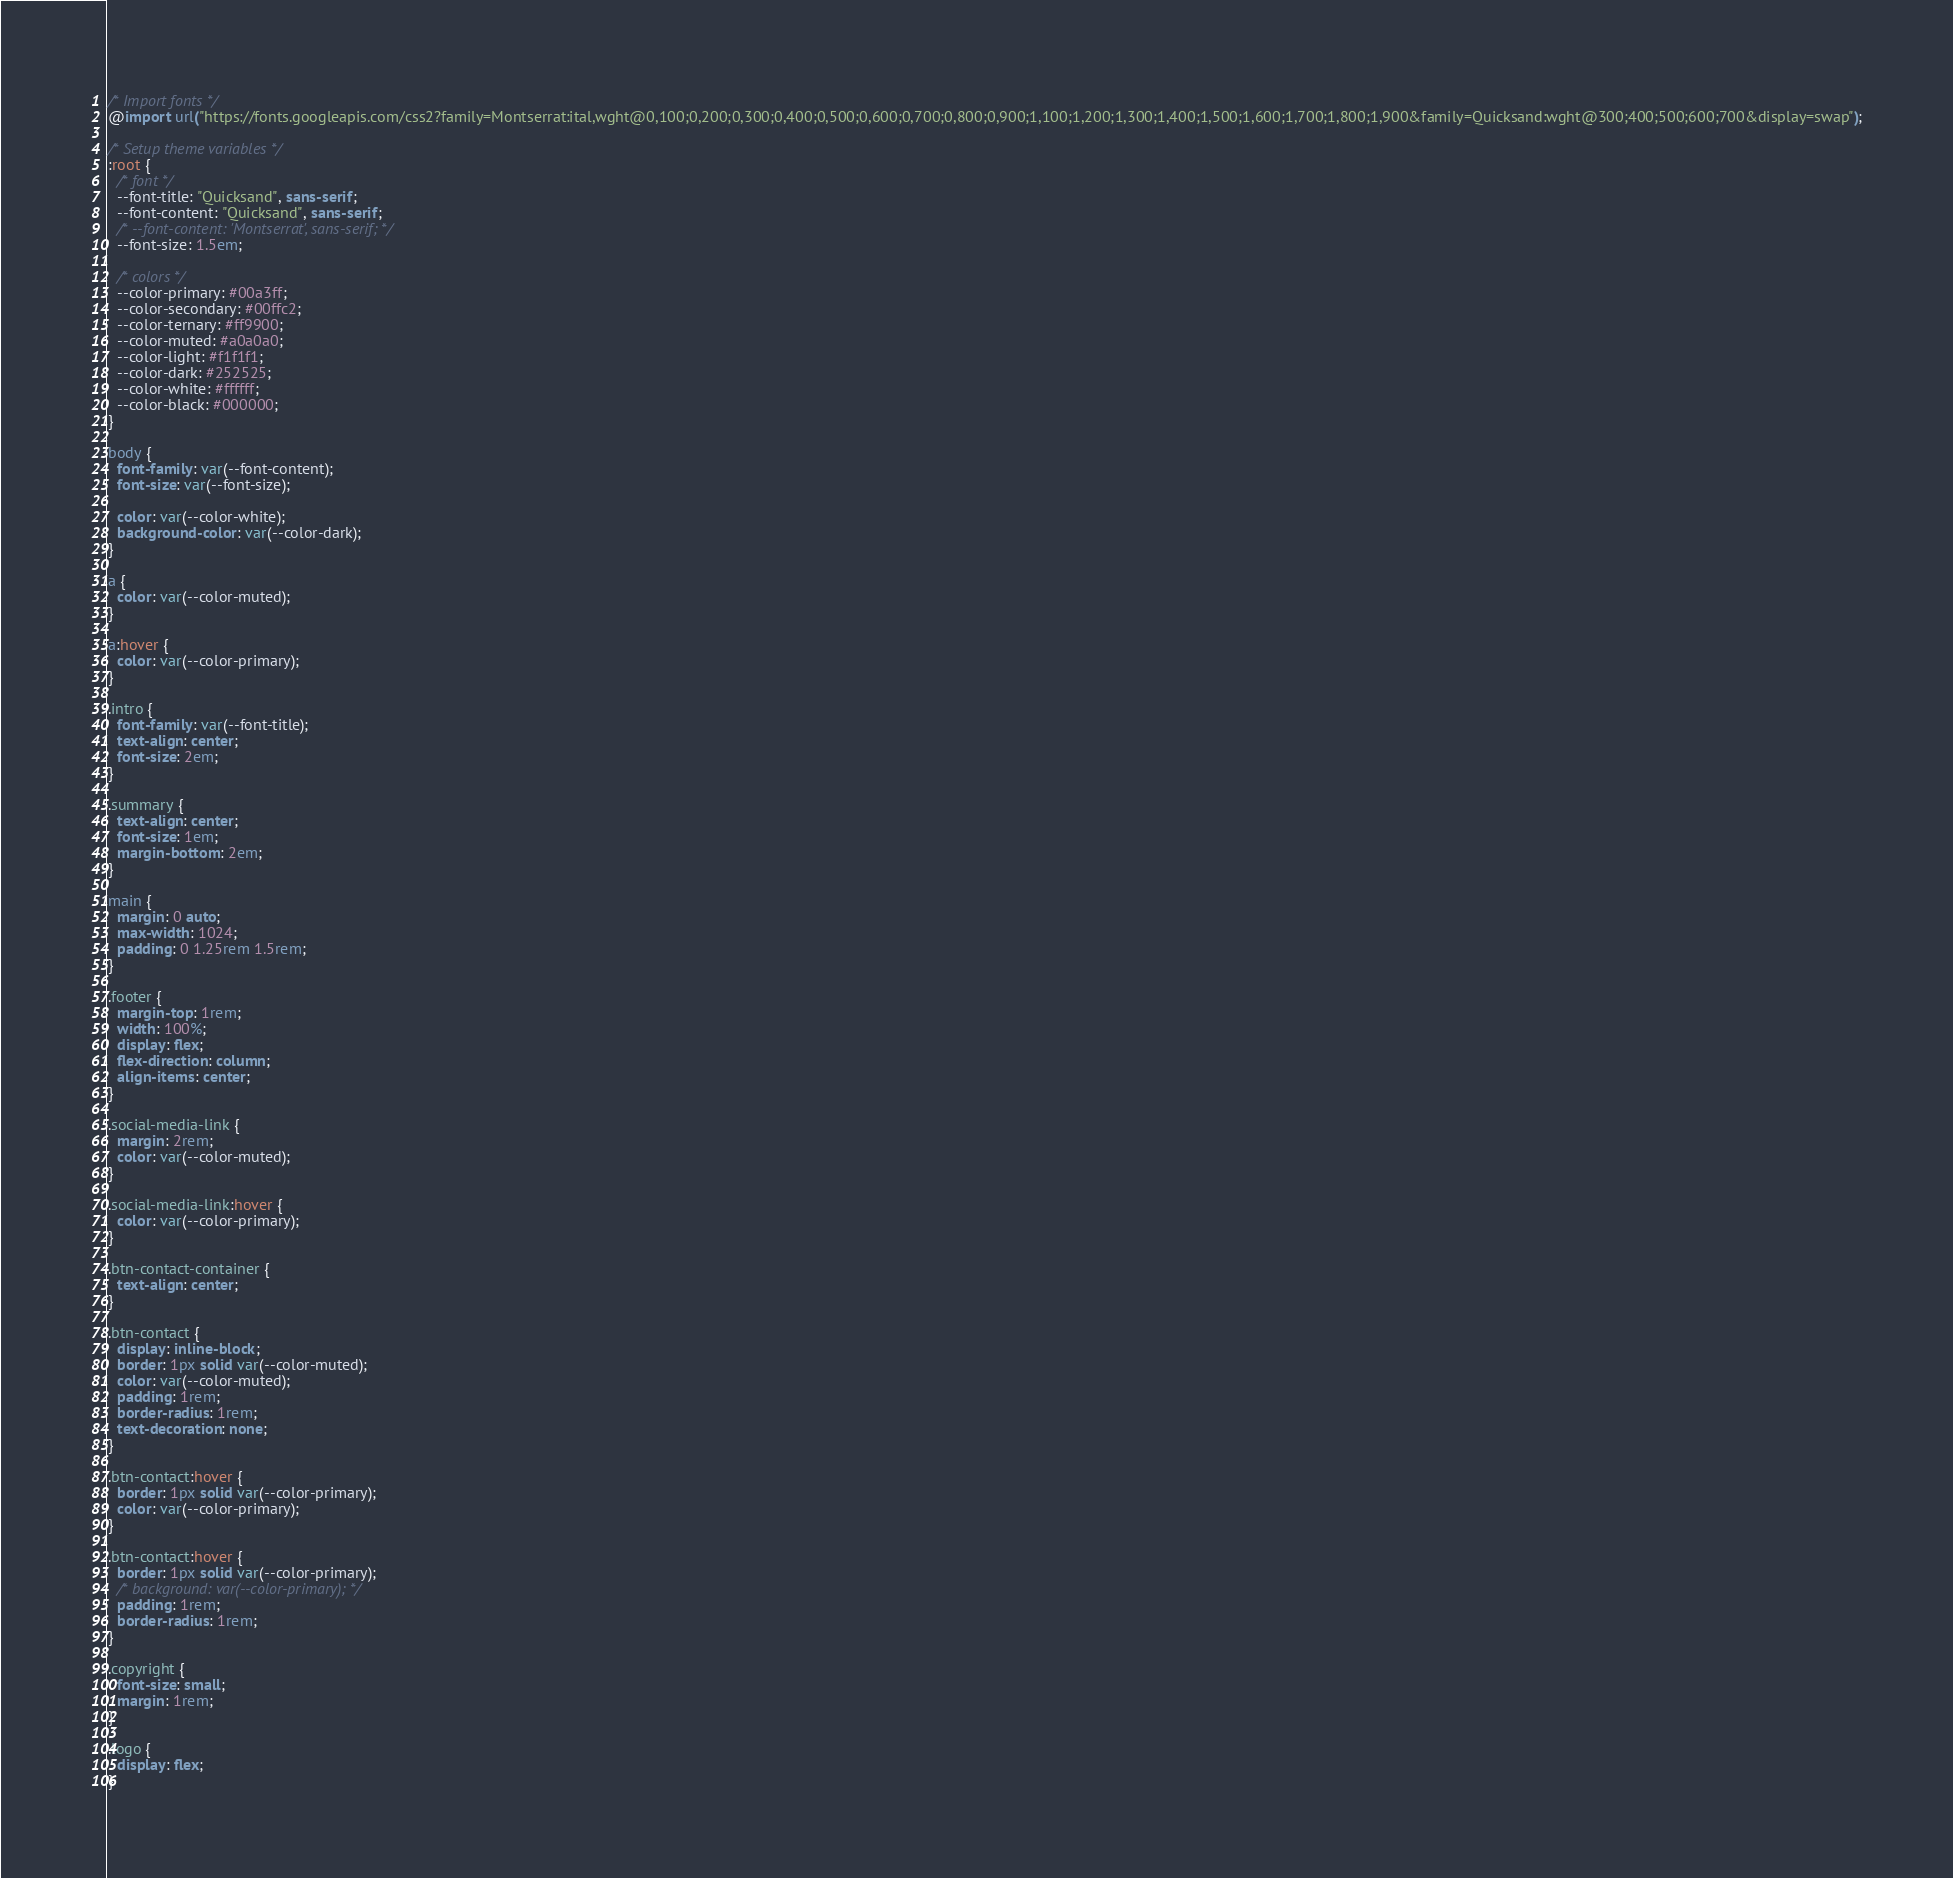<code> <loc_0><loc_0><loc_500><loc_500><_CSS_>/* Import fonts */
@import url("https://fonts.googleapis.com/css2?family=Montserrat:ital,wght@0,100;0,200;0,300;0,400;0,500;0,600;0,700;0,800;0,900;1,100;1,200;1,300;1,400;1,500;1,600;1,700;1,800;1,900&family=Quicksand:wght@300;400;500;600;700&display=swap");

/* Setup theme variables */
:root {
  /* font */
  --font-title: "Quicksand", sans-serif;
  --font-content: "Quicksand", sans-serif;
  /* --font-content: 'Montserrat', sans-serif; */
  --font-size: 1.5em;

  /* colors */
  --color-primary: #00a3ff;
  --color-secondary: #00ffc2;
  --color-ternary: #ff9900;
  --color-muted: #a0a0a0;
  --color-light: #f1f1f1;
  --color-dark: #252525;
  --color-white: #ffffff;
  --color-black: #000000;
}

body {
  font-family: var(--font-content);
  font-size: var(--font-size);

  color: var(--color-white);
  background-color: var(--color-dark);
}

a {
  color: var(--color-muted);
}

a:hover {
  color: var(--color-primary);
}

.intro {
  font-family: var(--font-title);
  text-align: center;
  font-size: 2em;
}

.summary {
  text-align: center;
  font-size: 1em;
  margin-bottom: 2em;
}

main {
  margin: 0 auto;
  max-width: 1024;
  padding: 0 1.25rem 1.5rem;
}

.footer {
  margin-top: 1rem;
  width: 100%;
  display: flex;
  flex-direction: column;
  align-items: center;
}

.social-media-link {
  margin: 2rem;
  color: var(--color-muted);
}

.social-media-link:hover {
  color: var(--color-primary);
}

.btn-contact-container {
  text-align: center;
}

.btn-contact {
  display: inline-block;
  border: 1px solid var(--color-muted);
  color: var(--color-muted);
  padding: 1rem;
  border-radius: 1rem;
  text-decoration: none;
}

.btn-contact:hover {
  border: 1px solid var(--color-primary);
  color: var(--color-primary);
}

.btn-contact:hover {
  border: 1px solid var(--color-primary);
  /* background: var(--color-primary); */
  padding: 1rem;
  border-radius: 1rem;
}

.copyright {
  font-size: small;
  margin: 1rem;
}

.logo {
  display: flex;
}
</code> 